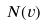Convert formula to latex. <formula><loc_0><loc_0><loc_500><loc_500>N ( v )</formula> 